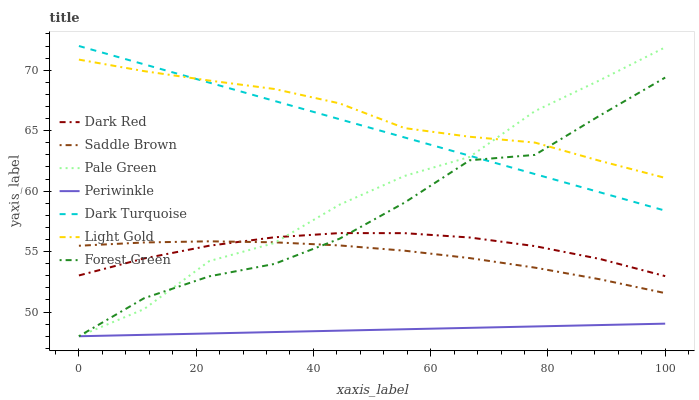Does Forest Green have the minimum area under the curve?
Answer yes or no. No. Does Forest Green have the maximum area under the curve?
Answer yes or no. No. Is Forest Green the smoothest?
Answer yes or no. No. Is Forest Green the roughest?
Answer yes or no. No. Does Dark Turquoise have the lowest value?
Answer yes or no. No. Does Forest Green have the highest value?
Answer yes or no. No. Is Periwinkle less than Dark Red?
Answer yes or no. Yes. Is Dark Turquoise greater than Saddle Brown?
Answer yes or no. Yes. Does Periwinkle intersect Dark Red?
Answer yes or no. No. 